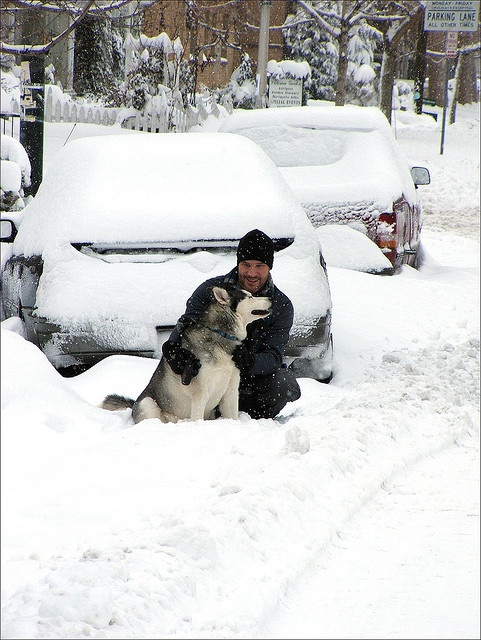Describe the objects in this image and their specific colors. I can see car in black, white, darkgray, and gray tones, car in black, white, darkgray, and gray tones, dog in black, darkgray, gray, and lightgray tones, and people in black, gray, brown, and white tones in this image. 